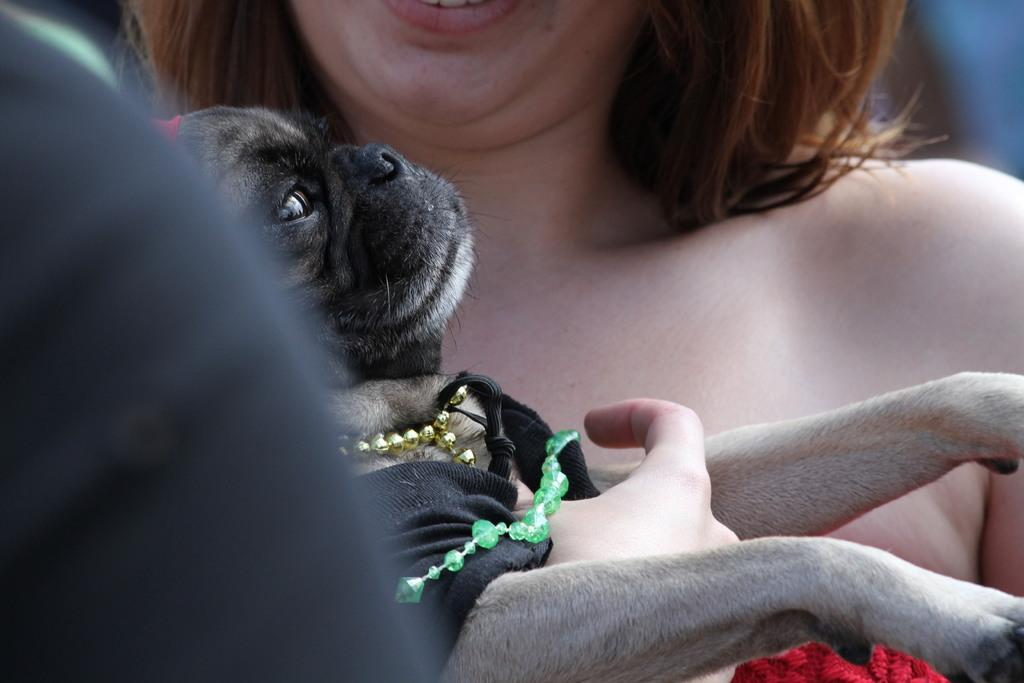Who is the main subject in the image? There is a woman in the image. What is the woman wearing? The woman is wearing a red dress. What is the woman holding in her hands? The woman is holding a puppy in her hands. What year is the woman wearing the trousers in the image? The image does not show the woman wearing trousers, and there is no indication of a specific year. 